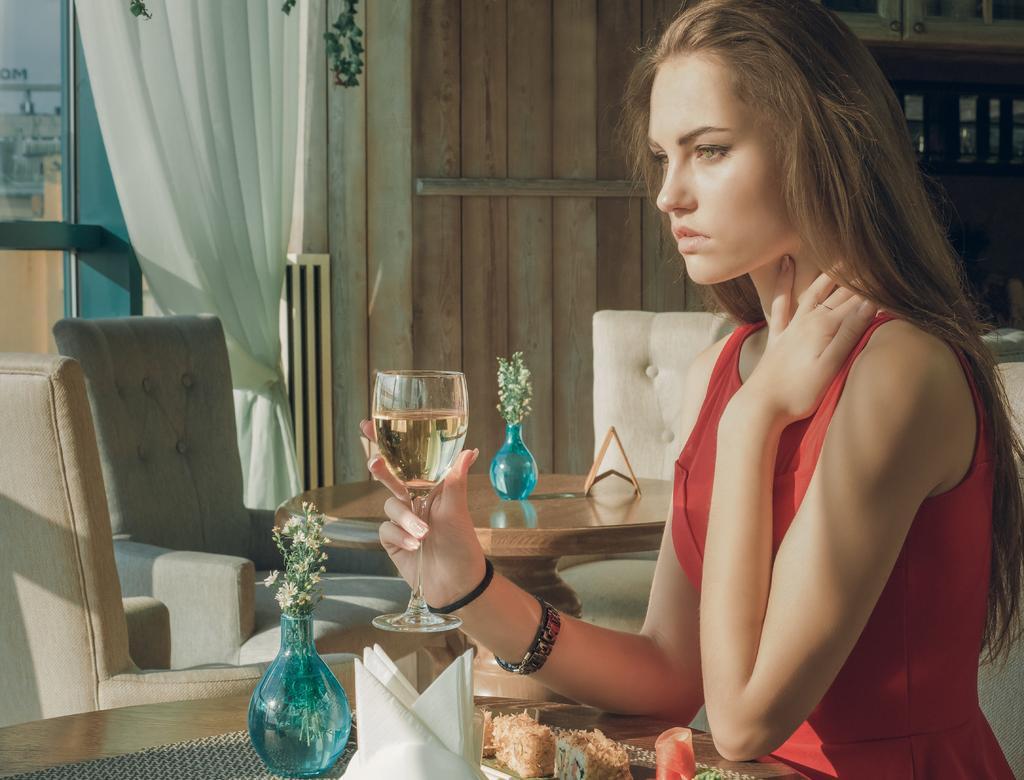In one or two sentences, can you explain what this image depicts? In this image, we can see a woman sitting and she is holding a glass, we can see a table, we can see some sofas, there is a curtain and we can see the window. 